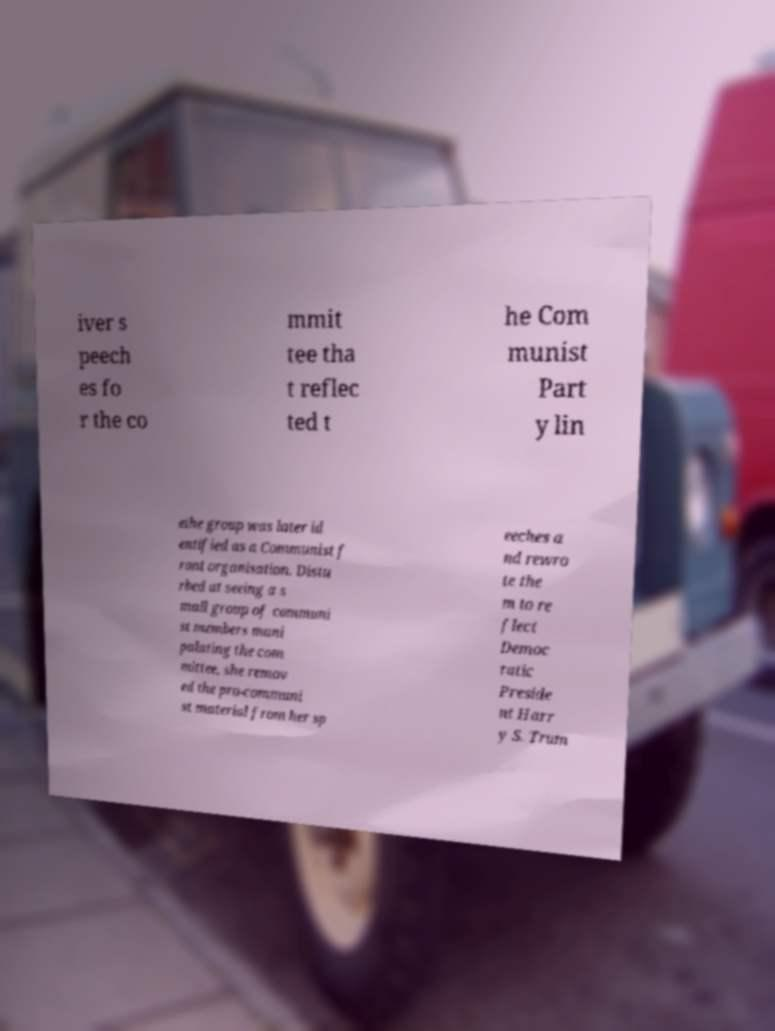Please read and relay the text visible in this image. What does it say? iver s peech es fo r the co mmit tee tha t reflec ted t he Com munist Part y lin ethe group was later id entified as a Communist f ront organisation. Distu rbed at seeing a s mall group of communi st members mani pulating the com mittee, she remov ed the pro-communi st material from her sp eeches a nd rewro te the m to re flect Democ ratic Preside nt Harr y S. Trum 